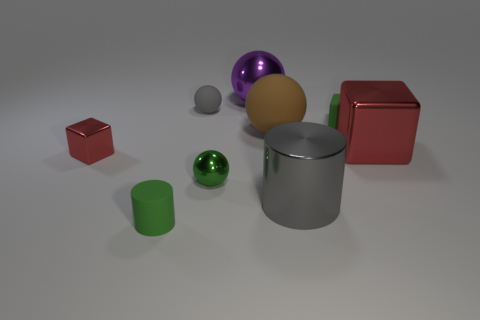Does the tiny green object that is in front of the gray cylinder have the same shape as the brown matte thing?
Your answer should be compact. No. How many things are large red shiny blocks or big things right of the small green matte cube?
Offer a very short reply. 1. Is the number of large purple rubber blocks less than the number of tiny rubber spheres?
Your answer should be compact. Yes. Are there more yellow balls than big gray cylinders?
Keep it short and to the point. No. How many other things are the same material as the large cylinder?
Provide a succinct answer. 4. How many rubber cylinders are in front of the metallic sphere behind the green metal ball behind the matte cylinder?
Offer a very short reply. 1. What number of metal objects are red cubes or tiny spheres?
Ensure brevity in your answer.  3. How big is the ball that is in front of the red object that is on the right side of the purple ball?
Offer a very short reply. Small. Is the color of the large thing behind the tiny gray ball the same as the cylinder in front of the large gray cylinder?
Your response must be concise. No. The matte thing that is behind the large matte thing and on the left side of the purple metal thing is what color?
Your response must be concise. Gray. 